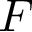Convert formula to latex. <formula><loc_0><loc_0><loc_500><loc_500>F</formula> 